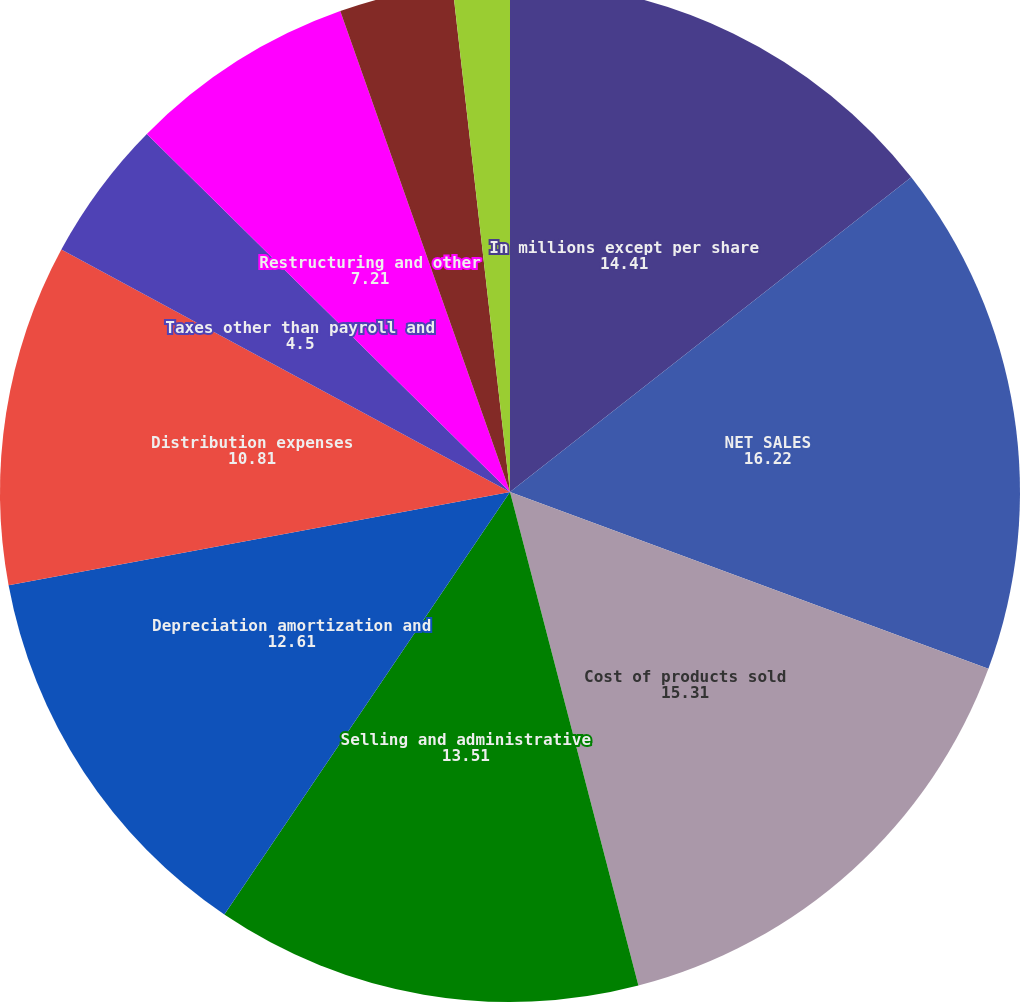Convert chart to OTSL. <chart><loc_0><loc_0><loc_500><loc_500><pie_chart><fcel>In millions except per share<fcel>NET SALES<fcel>Cost of products sold<fcel>Selling and administrative<fcel>Depreciation amortization and<fcel>Distribution expenses<fcel>Taxes other than payroll and<fcel>Restructuring and other<fcel>held for sale<fcel>Reversals of reserves no<nl><fcel>14.41%<fcel>16.22%<fcel>15.31%<fcel>13.51%<fcel>12.61%<fcel>10.81%<fcel>4.5%<fcel>7.21%<fcel>3.6%<fcel>1.8%<nl></chart> 